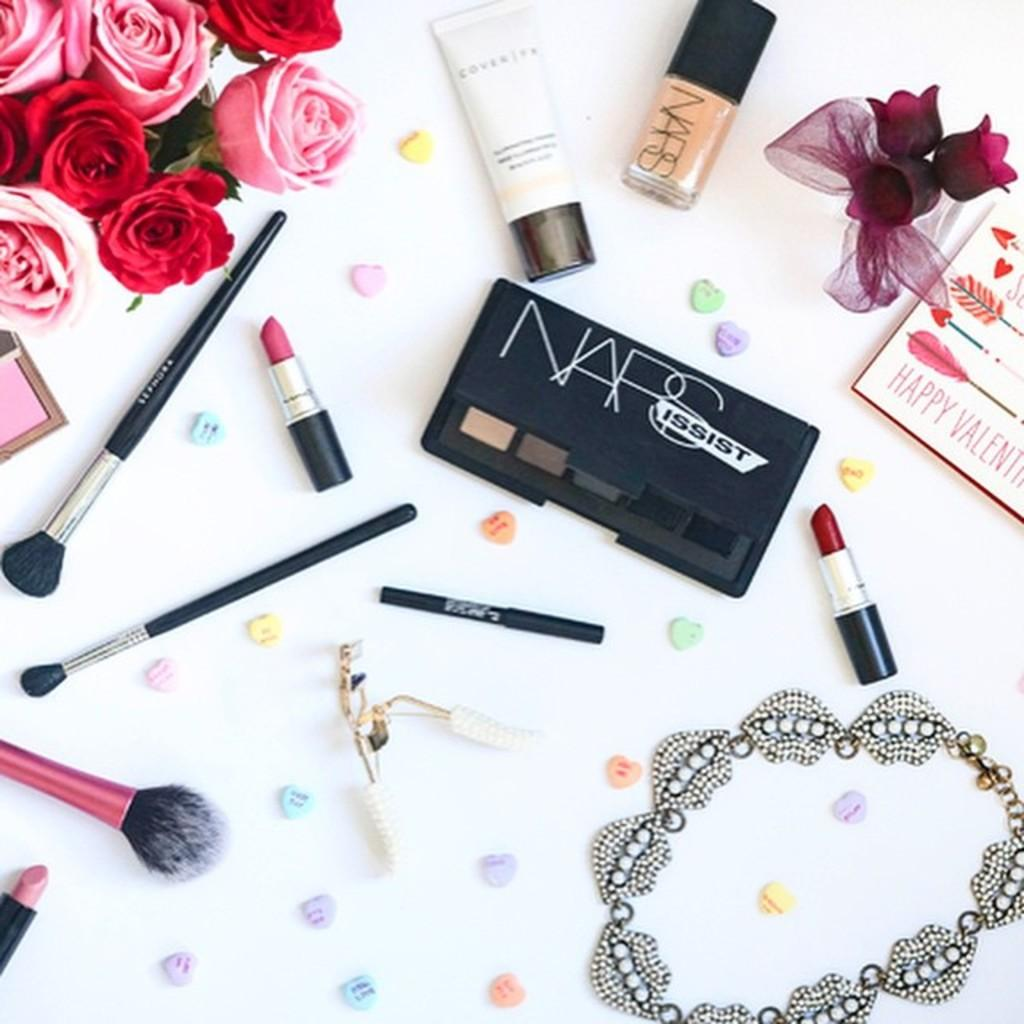Provide a one-sentence caption for the provided image. Here we have a marketing picture for NARS Cosmetics. 